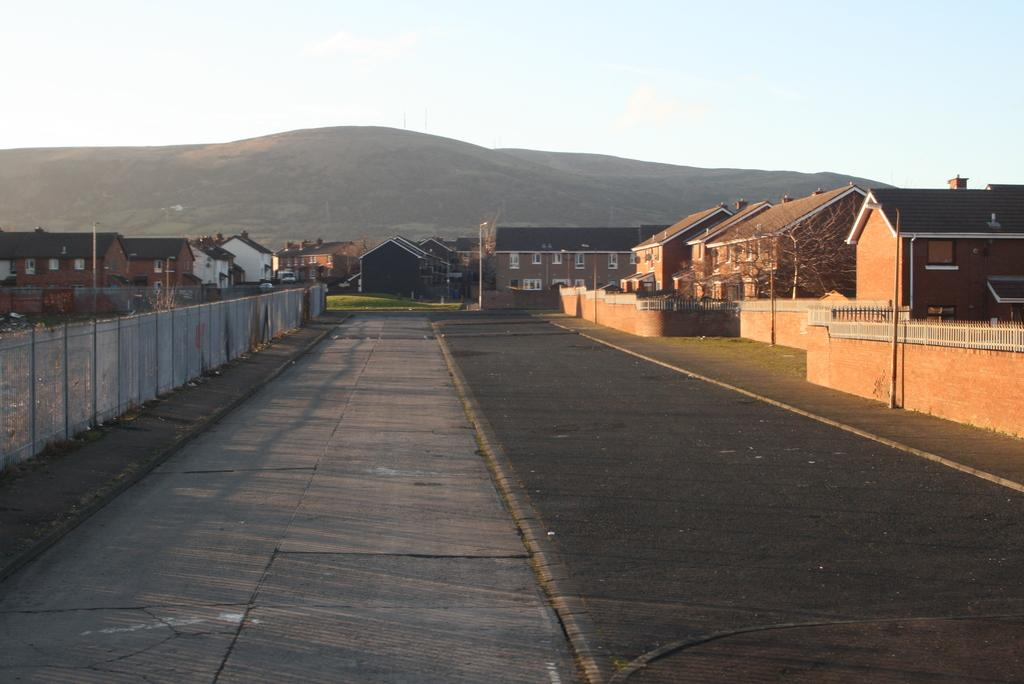What type of structures can be seen in the image? There are houses in the image. What other objects can be seen in the image? There are poles, windows, trees, mountains, a fence, a wall, and a road in the image. What is visible in the background of the image? The sky is visible in the background of the image. What type of fruit is being harvested by the creator in the image? There is no fruit or creator present in the image. What is the mass of the wall in the image? The mass of the wall cannot be determined from the image alone, as it would require additional information about the materials and dimensions of the wall. 